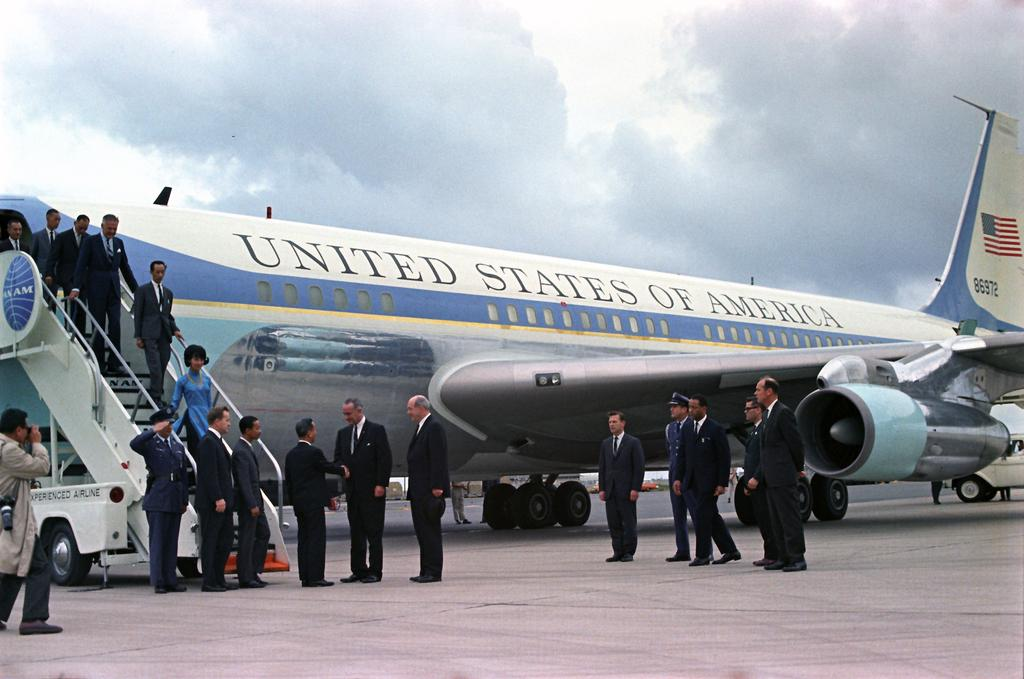<image>
Write a terse but informative summary of the picture. a plane that is from the United States of America 